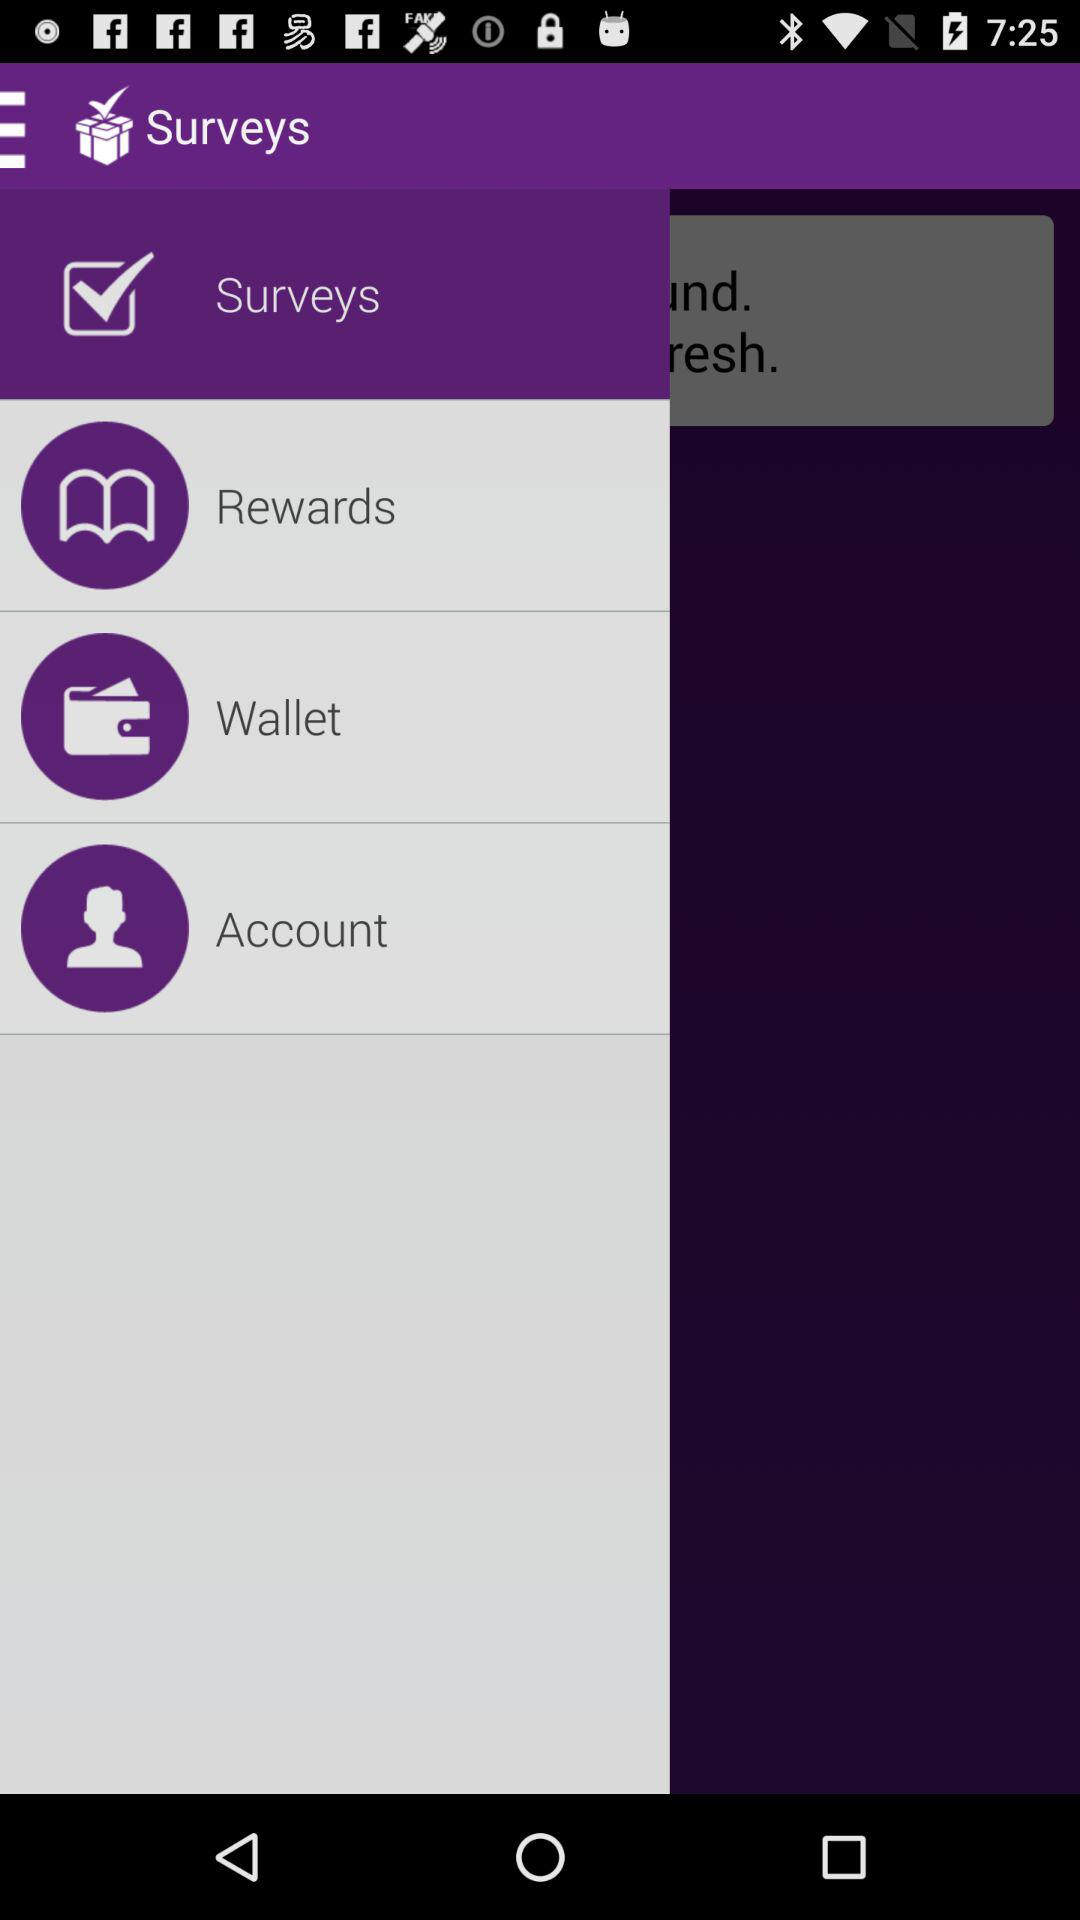What is the application name? The application name is "Surveys". 